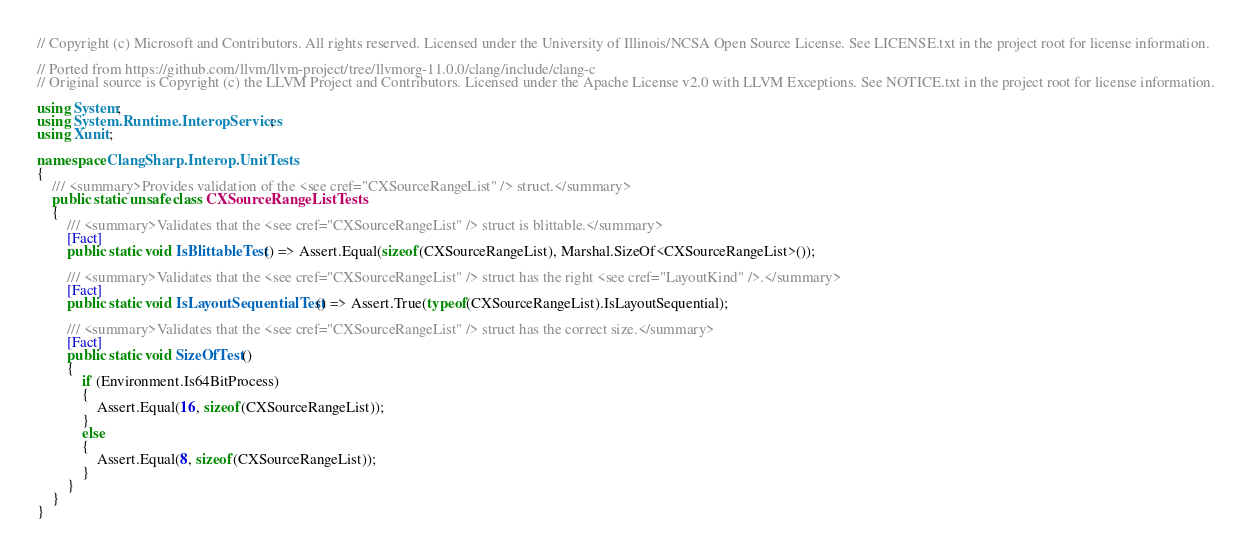<code> <loc_0><loc_0><loc_500><loc_500><_C#_>// Copyright (c) Microsoft and Contributors. All rights reserved. Licensed under the University of Illinois/NCSA Open Source License. See LICENSE.txt in the project root for license information.

// Ported from https://github.com/llvm/llvm-project/tree/llvmorg-11.0.0/clang/include/clang-c
// Original source is Copyright (c) the LLVM Project and Contributors. Licensed under the Apache License v2.0 with LLVM Exceptions. See NOTICE.txt in the project root for license information.

using System;
using System.Runtime.InteropServices;
using Xunit;

namespace ClangSharp.Interop.UnitTests
{
    /// <summary>Provides validation of the <see cref="CXSourceRangeList" /> struct.</summary>
    public static unsafe class CXSourceRangeListTests
    {
        /// <summary>Validates that the <see cref="CXSourceRangeList" /> struct is blittable.</summary>
        [Fact]
        public static void IsBlittableTest() => Assert.Equal(sizeof(CXSourceRangeList), Marshal.SizeOf<CXSourceRangeList>());

        /// <summary>Validates that the <see cref="CXSourceRangeList" /> struct has the right <see cref="LayoutKind" />.</summary>
        [Fact]
        public static void IsLayoutSequentialTest() => Assert.True(typeof(CXSourceRangeList).IsLayoutSequential);

        /// <summary>Validates that the <see cref="CXSourceRangeList" /> struct has the correct size.</summary>
        [Fact]
        public static void SizeOfTest()
        {
            if (Environment.Is64BitProcess)
            {
                Assert.Equal(16, sizeof(CXSourceRangeList));
            }
            else
            {
                Assert.Equal(8, sizeof(CXSourceRangeList));
            }
        }
    }
}
</code> 